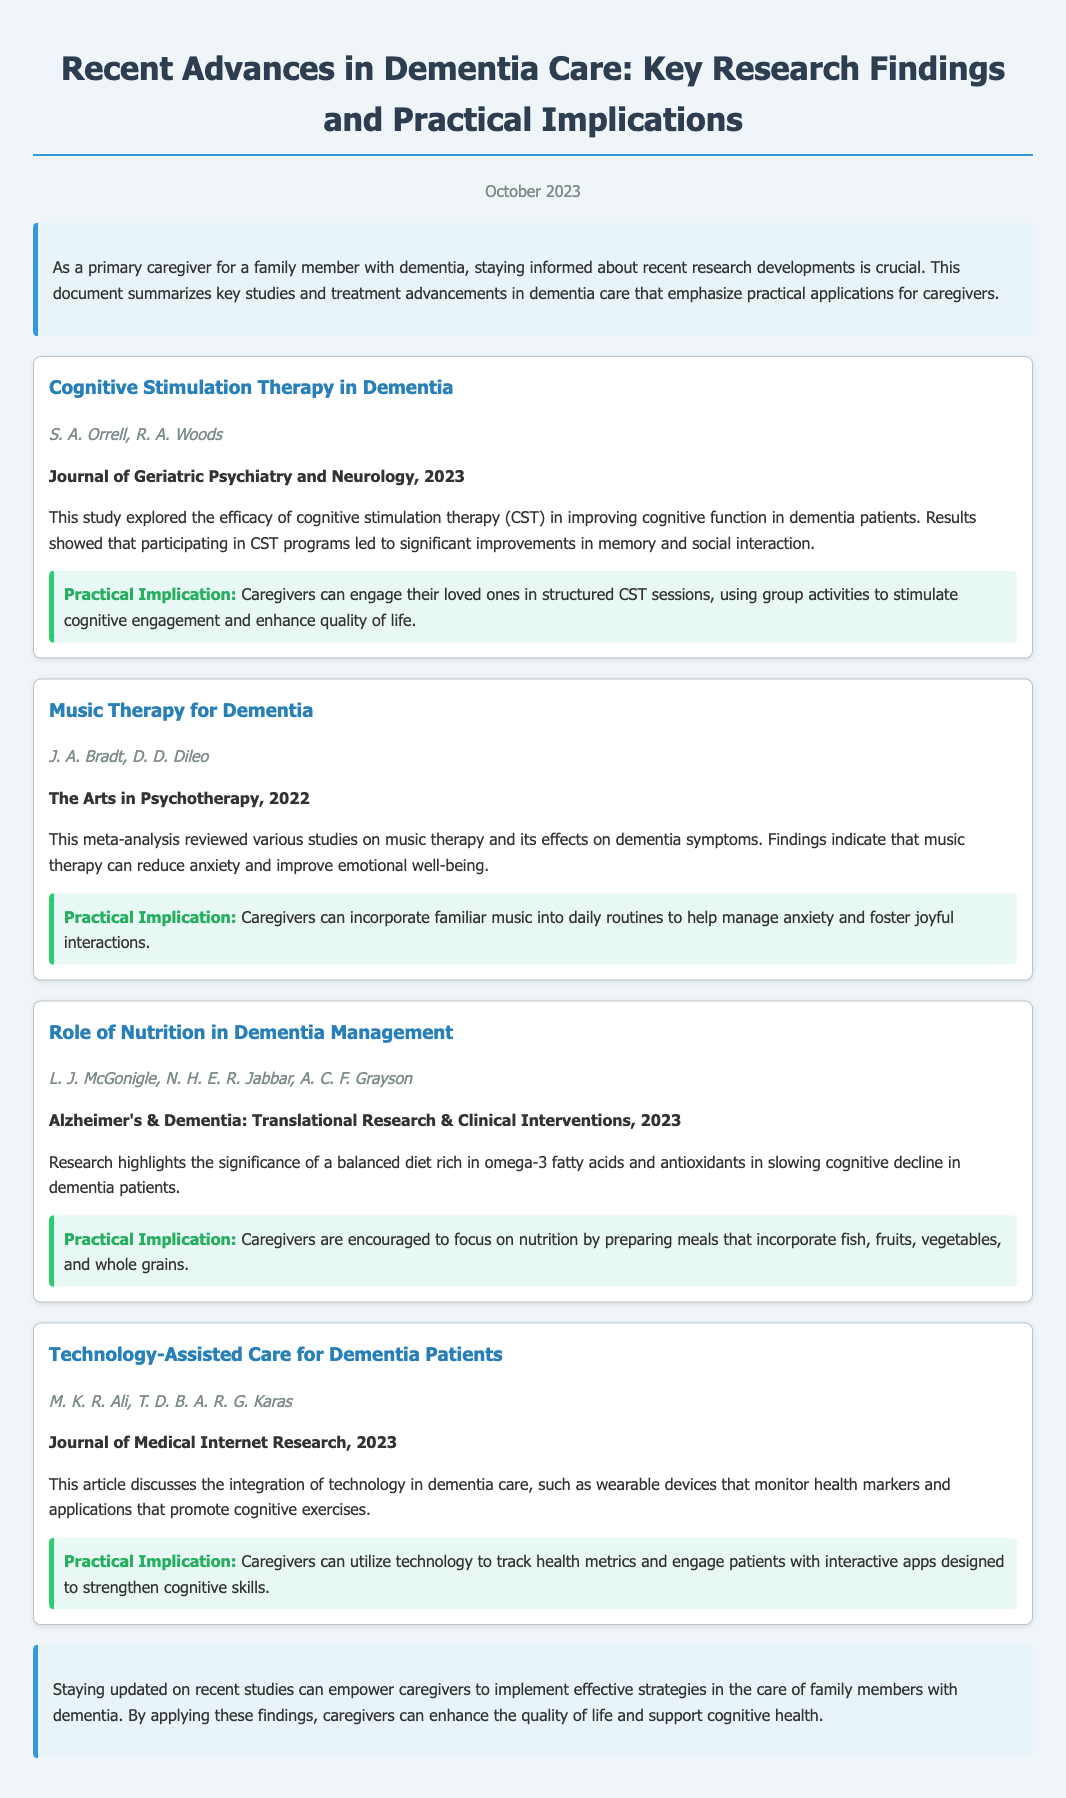What is the title of the document? The document title is explicitly stated at the top, providing the main focus of the content.
Answer: Recent Advances in Dementia Care: Key Research Findings and Practical Implications Who authored the study on Cognitive Stimulation Therapy? The authors are specifically listed under each study, so the information can be easily found.
Answer: S. A. Orrell, R. A. Woods What journal published the study on the role of Nutrition in Dementia Management? The journal name is noted below the study title, which indicates the source of the research findings.
Answer: Alzheimer's & Dementia: Translational Research & Clinical Interventions What practical implication is suggested for caregivers regarding Music Therapy? The practical implication is mentioned in a specific section following each study, summarizing the application for caregivers.
Answer: Incorporate familiar music into daily routines When was the document published? The publication date is prominently displayed at the beginning of the document, giving context to the timeliness of the information.
Answer: October 2023 Which study discusses the integration of technology in dementia care? Each study is clearly titled, allowing readers to identify the focus of the research quickly.
Answer: Technology-Assisted Care for Dementia Patients What is recommended for caregivers to enhance nutrition? The summary section provides actionable suggestions based on the research findings for caregivers in their daily practices.
Answer: Prepare meals that incorporate fish, fruits, vegetables, and whole grains What is the overall conclusion of the document? The conclusion summarizes the key takeaway from the information presented, emphasizing its importance for caregivers.
Answer: Staying updated on recent studies can empower caregivers to implement effective strategies 